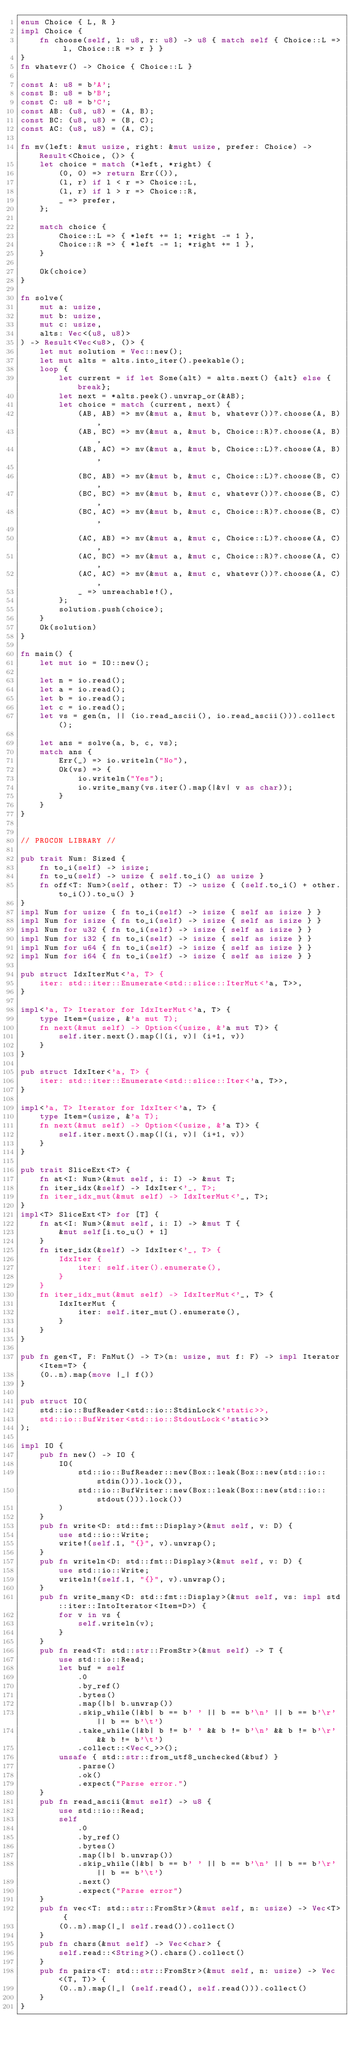<code> <loc_0><loc_0><loc_500><loc_500><_Rust_>enum Choice { L, R }
impl Choice {
    fn choose(self, l: u8, r: u8) -> u8 { match self { Choice::L => l, Choice::R => r } }
}
fn whatevr() -> Choice { Choice::L }

const A: u8 = b'A';
const B: u8 = b'B';
const C: u8 = b'C';
const AB: (u8, u8) = (A, B);
const BC: (u8, u8) = (B, C);
const AC: (u8, u8) = (A, C);

fn mv(left: &mut usize, right: &mut usize, prefer: Choice) -> Result<Choice, ()> {
    let choice = match (*left, *right) {
        (0, 0) => return Err(()),
        (l, r) if l < r => Choice::L,
        (l, r) if l > r => Choice::R,
        _ => prefer,
    };

    match choice {
        Choice::L => { *left += 1; *right -= 1 },
        Choice::R => { *left -= 1; *right += 1 },
    }

    Ok(choice)
}

fn solve(
    mut a: usize,
    mut b: usize,
    mut c: usize,
    alts: Vec<(u8, u8)>
) -> Result<Vec<u8>, ()> {
    let mut solution = Vec::new();
    let mut alts = alts.into_iter().peekable();
    loop {
        let current = if let Some(alt) = alts.next() {alt} else {break};
        let next = *alts.peek().unwrap_or(&AB);
        let choice = match (current, next) {
            (AB, AB) => mv(&mut a, &mut b, whatevr())?.choose(A, B),
            (AB, BC) => mv(&mut a, &mut b, Choice::R)?.choose(A, B),
            (AB, AC) => mv(&mut a, &mut b, Choice::L)?.choose(A, B),

            (BC, AB) => mv(&mut b, &mut c, Choice::L)?.choose(B, C),
            (BC, BC) => mv(&mut b, &mut c, whatevr())?.choose(B, C),
            (BC, AC) => mv(&mut b, &mut c, Choice::R)?.choose(B, C),

            (AC, AB) => mv(&mut a, &mut c, Choice::L)?.choose(A, C),
            (AC, BC) => mv(&mut a, &mut c, Choice::R)?.choose(A, C),
            (AC, AC) => mv(&mut a, &mut c, whatevr())?.choose(A, C),
            _ => unreachable!(),
        };
        solution.push(choice);
    }
    Ok(solution)
}

fn main() {
    let mut io = IO::new();

    let n = io.read();
    let a = io.read();
    let b = io.read();
    let c = io.read();
    let vs = gen(n, || (io.read_ascii(), io.read_ascii())).collect();

    let ans = solve(a, b, c, vs);
    match ans {
        Err(_) => io.writeln("No"),
        Ok(vs) => {
            io.writeln("Yes");
            io.write_many(vs.iter().map(|&v| v as char));
        }
    }
}


// PROCON LIBRARY //

pub trait Num: Sized {
    fn to_i(self) -> isize;
    fn to_u(self) -> usize { self.to_i() as usize }
    fn off<T: Num>(self, other: T) -> usize { (self.to_i() + other.to_i()).to_u() }
}
impl Num for usize { fn to_i(self) -> isize { self as isize } }
impl Num for isize { fn to_i(self) -> isize { self as isize } }
impl Num for u32 { fn to_i(self) -> isize { self as isize } }
impl Num for i32 { fn to_i(self) -> isize { self as isize } }
impl Num for u64 { fn to_i(self) -> isize { self as isize } }
impl Num for i64 { fn to_i(self) -> isize { self as isize } }

pub struct IdxIterMut<'a, T> {
    iter: std::iter::Enumerate<std::slice::IterMut<'a, T>>,
}

impl<'a, T> Iterator for IdxIterMut<'a, T> {
    type Item=(usize, &'a mut T);
    fn next(&mut self) -> Option<(usize, &'a mut T)> {
        self.iter.next().map(|(i, v)| (i+1, v))
    }
}

pub struct IdxIter<'a, T> {
    iter: std::iter::Enumerate<std::slice::Iter<'a, T>>,
}

impl<'a, T> Iterator for IdxIter<'a, T> {
    type Item=(usize, &'a T);
    fn next(&mut self) -> Option<(usize, &'a T)> {
        self.iter.next().map(|(i, v)| (i+1, v))
    }
}

pub trait SliceExt<T> {
    fn at<I: Num>(&mut self, i: I) -> &mut T;
    fn iter_idx(&self) -> IdxIter<'_, T>;
    fn iter_idx_mut(&mut self) -> IdxIterMut<'_, T>;
}
impl<T> SliceExt<T> for [T] {
    fn at<I: Num>(&mut self, i: I) -> &mut T {
        &mut self[i.to_u() + 1]
    }
    fn iter_idx(&self) -> IdxIter<'_, T> {
        IdxIter {
            iter: self.iter().enumerate(),
        }
    }
    fn iter_idx_mut(&mut self) -> IdxIterMut<'_, T> {
        IdxIterMut {
            iter: self.iter_mut().enumerate(),
        }
    }
}

pub fn gen<T, F: FnMut() -> T>(n: usize, mut f: F) -> impl Iterator<Item=T> {
    (0..n).map(move |_| f())
}

pub struct IO(
    std::io::BufReader<std::io::StdinLock<'static>>,
    std::io::BufWriter<std::io::StdoutLock<'static>>
);
 
impl IO {
    pub fn new() -> IO {
        IO(
            std::io::BufReader::new(Box::leak(Box::new(std::io::stdin())).lock()),
            std::io::BufWriter::new(Box::leak(Box::new(std::io::stdout())).lock())
        )
    }
    pub fn write<D: std::fmt::Display>(&mut self, v: D) {
        use std::io::Write;
        write!(self.1, "{}", v).unwrap();
    }
    pub fn writeln<D: std::fmt::Display>(&mut self, v: D) {
        use std::io::Write;
        writeln!(self.1, "{}", v).unwrap();
    }
    pub fn write_many<D: std::fmt::Display>(&mut self, vs: impl std::iter::IntoIterator<Item=D>) {
        for v in vs {
            self.writeln(v);
        }
    }
    pub fn read<T: std::str::FromStr>(&mut self) -> T {
        use std::io::Read;
        let buf = self
            .0
            .by_ref()
            .bytes()
            .map(|b| b.unwrap())
            .skip_while(|&b| b == b' ' || b == b'\n' || b == b'\r' || b == b'\t')
            .take_while(|&b| b != b' ' && b != b'\n' && b != b'\r' && b != b'\t')
            .collect::<Vec<_>>();
        unsafe { std::str::from_utf8_unchecked(&buf) }
            .parse()
            .ok()
            .expect("Parse error.")
    }
    pub fn read_ascii(&mut self) -> u8 {
        use std::io::Read;
        self
            .0
            .by_ref()
            .bytes()
            .map(|b| b.unwrap())
            .skip_while(|&b| b == b' ' || b == b'\n' || b == b'\r' || b == b'\t')
            .next()
            .expect("Parse error")
    }
    pub fn vec<T: std::str::FromStr>(&mut self, n: usize) -> Vec<T> {
        (0..n).map(|_| self.read()).collect()
    }
    pub fn chars(&mut self) -> Vec<char> {
        self.read::<String>().chars().collect()
    }
    pub fn pairs<T: std::str::FromStr>(&mut self, n: usize) -> Vec<(T, T)> {
        (0..n).map(|_| (self.read(), self.read())).collect()
    }
}
</code> 